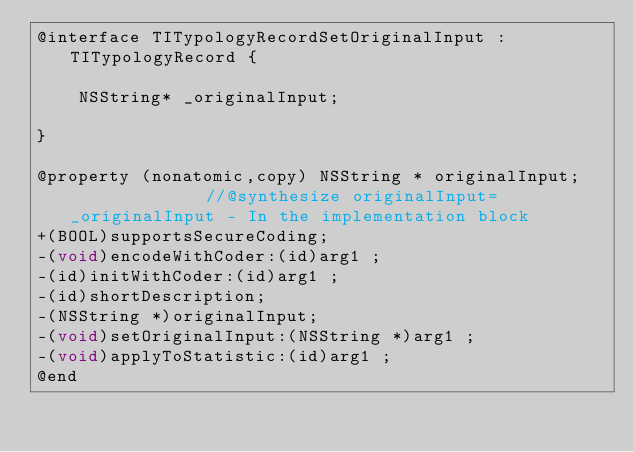<code> <loc_0><loc_0><loc_500><loc_500><_C_>@interface TITypologyRecordSetOriginalInput : TITypologyRecord {

	NSString* _originalInput;

}

@property (nonatomic,copy) NSString * originalInput;              //@synthesize originalInput=_originalInput - In the implementation block
+(BOOL)supportsSecureCoding;
-(void)encodeWithCoder:(id)arg1 ;
-(id)initWithCoder:(id)arg1 ;
-(id)shortDescription;
-(NSString *)originalInput;
-(void)setOriginalInput:(NSString *)arg1 ;
-(void)applyToStatistic:(id)arg1 ;
@end

</code> 